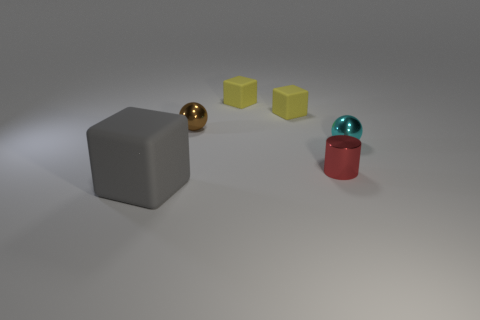Add 2 tiny purple cylinders. How many objects exist? 8 Subtract all spheres. How many objects are left? 4 Subtract all large things. Subtract all small rubber blocks. How many objects are left? 3 Add 3 yellow matte objects. How many yellow matte objects are left? 5 Add 6 cyan metal things. How many cyan metal things exist? 7 Subtract 1 gray blocks. How many objects are left? 5 